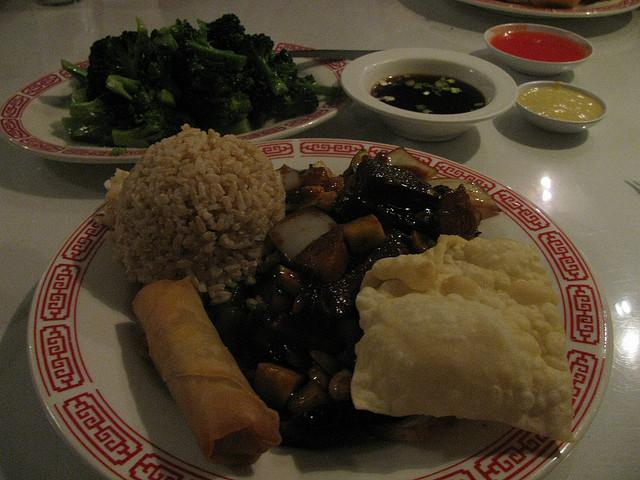What is used to sook the food?

Choices:
A) light
B) sun
C) coal
D) stove stove 